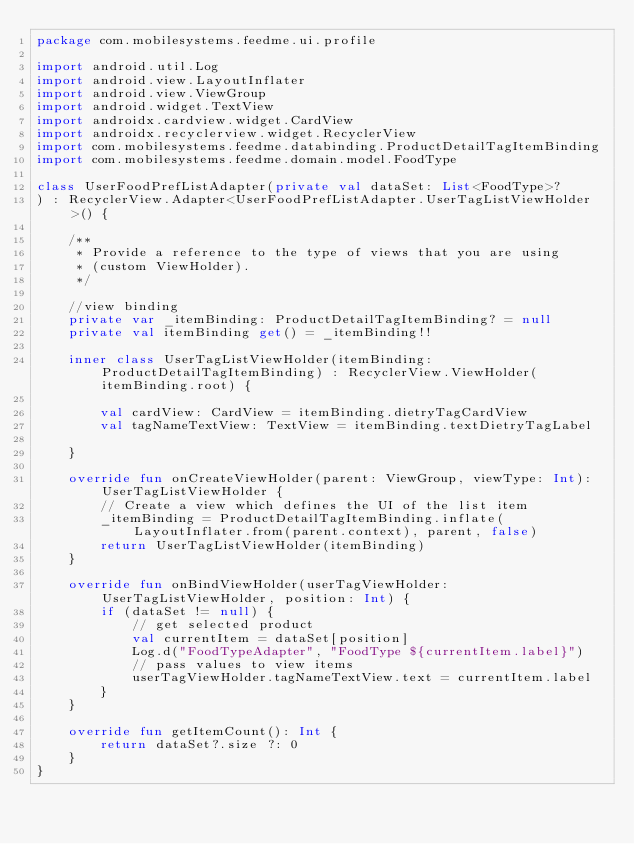Convert code to text. <code><loc_0><loc_0><loc_500><loc_500><_Kotlin_>package com.mobilesystems.feedme.ui.profile

import android.util.Log
import android.view.LayoutInflater
import android.view.ViewGroup
import android.widget.TextView
import androidx.cardview.widget.CardView
import androidx.recyclerview.widget.RecyclerView
import com.mobilesystems.feedme.databinding.ProductDetailTagItemBinding
import com.mobilesystems.feedme.domain.model.FoodType

class UserFoodPrefListAdapter(private val dataSet: List<FoodType>?
) : RecyclerView.Adapter<UserFoodPrefListAdapter.UserTagListViewHolder>() {

    /**
     * Provide a reference to the type of views that you are using
     * (custom ViewHolder).
     */

    //view binding
    private var _itemBinding: ProductDetailTagItemBinding? = null
    private val itemBinding get() = _itemBinding!!

    inner class UserTagListViewHolder(itemBinding: ProductDetailTagItemBinding) : RecyclerView.ViewHolder(itemBinding.root) {

        val cardView: CardView = itemBinding.dietryTagCardView
        val tagNameTextView: TextView = itemBinding.textDietryTagLabel

    }

    override fun onCreateViewHolder(parent: ViewGroup, viewType: Int): UserTagListViewHolder {
        // Create a view which defines the UI of the list item
        _itemBinding = ProductDetailTagItemBinding.inflate(LayoutInflater.from(parent.context), parent, false)
        return UserTagListViewHolder(itemBinding)
    }

    override fun onBindViewHolder(userTagViewHolder: UserTagListViewHolder, position: Int) {
        if (dataSet != null) {
            // get selected product
            val currentItem = dataSet[position]
            Log.d("FoodTypeAdapter", "FoodType ${currentItem.label}")
            // pass values to view items
            userTagViewHolder.tagNameTextView.text = currentItem.label
        }
    }

    override fun getItemCount(): Int {
        return dataSet?.size ?: 0
    }
}</code> 